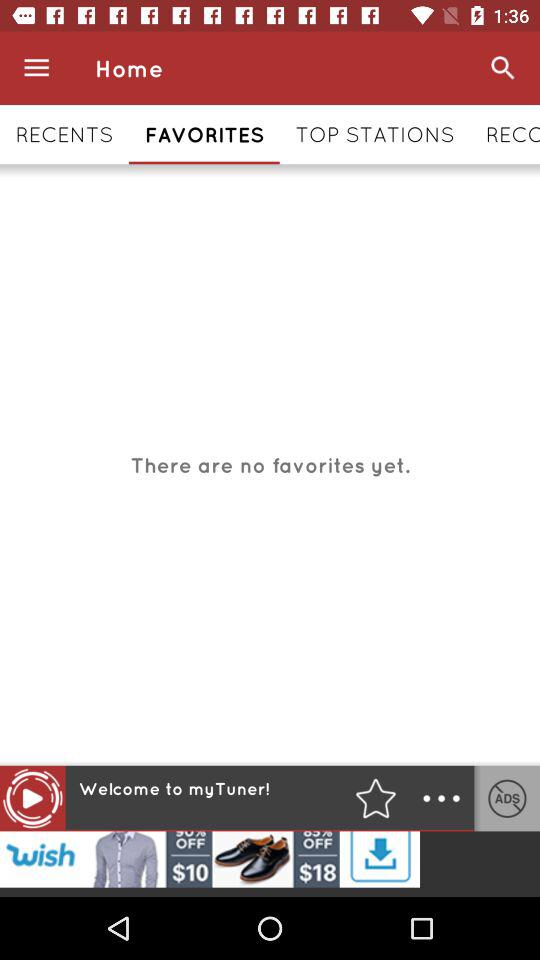Which tab is selected right now? The selected tab is "FAVORITES". 